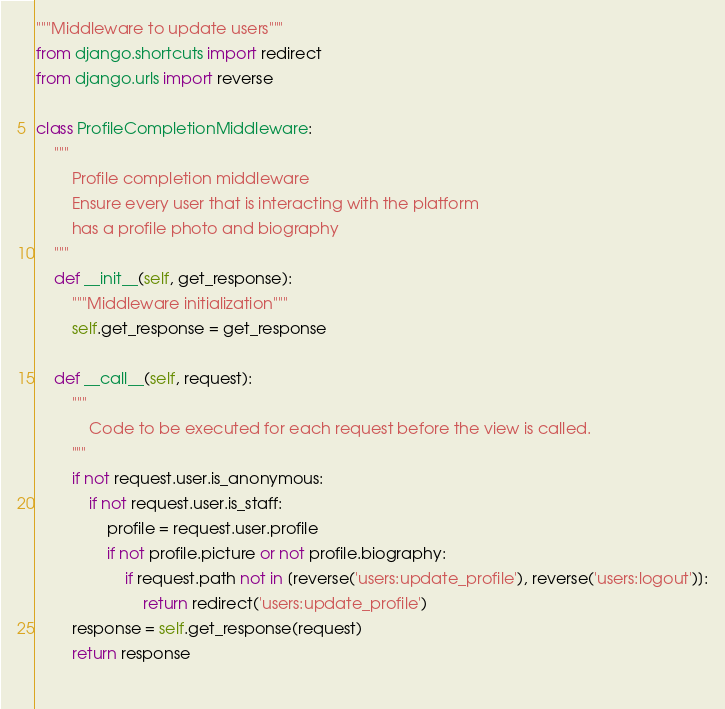<code> <loc_0><loc_0><loc_500><loc_500><_Python_>"""Middleware to update users"""
from django.shortcuts import redirect
from django.urls import reverse

class ProfileCompletionMiddleware:
    """
        Profile completion middleware
        Ensure every user that is interacting with the platform 
        has a profile photo and biography
    """
    def __init__(self, get_response):
        """Middleware initialization"""
        self.get_response = get_response

    def __call__(self, request):
        """
            Code to be executed for each request before the view is called.
        """
        if not request.user.is_anonymous:
            if not request.user.is_staff:
                profile = request.user.profile
                if not profile.picture or not profile.biography:
                    if request.path not in [reverse('users:update_profile'), reverse('users:logout')]:
                        return redirect('users:update_profile')
        response = self.get_response(request)
        return response
        </code> 